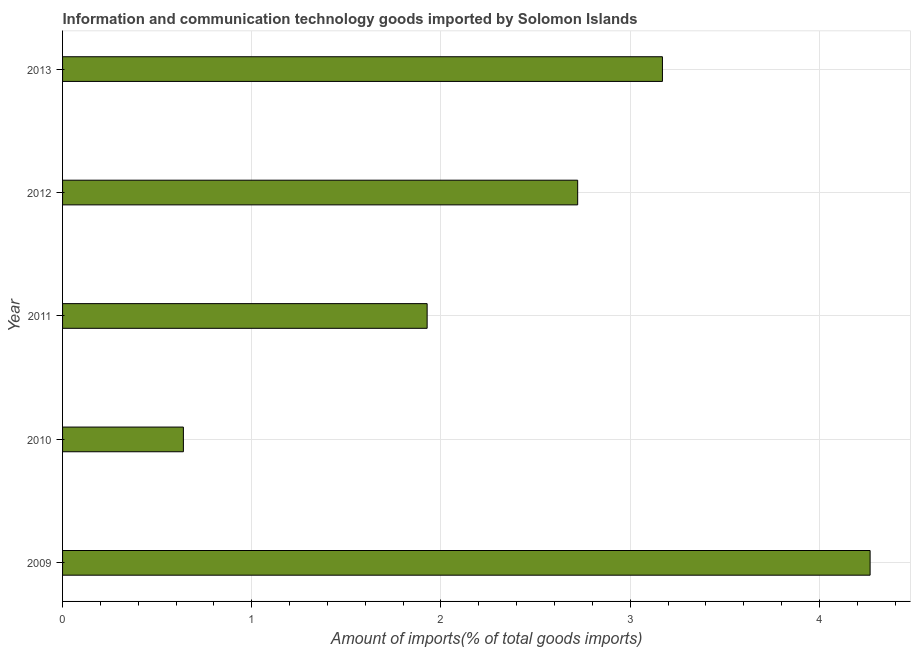What is the title of the graph?
Provide a short and direct response. Information and communication technology goods imported by Solomon Islands. What is the label or title of the X-axis?
Offer a very short reply. Amount of imports(% of total goods imports). What is the amount of ict goods imports in 2009?
Your answer should be compact. 4.27. Across all years, what is the maximum amount of ict goods imports?
Make the answer very short. 4.27. Across all years, what is the minimum amount of ict goods imports?
Offer a very short reply. 0.64. In which year was the amount of ict goods imports minimum?
Offer a terse response. 2010. What is the sum of the amount of ict goods imports?
Give a very brief answer. 12.73. What is the difference between the amount of ict goods imports in 2010 and 2011?
Offer a terse response. -1.29. What is the average amount of ict goods imports per year?
Provide a succinct answer. 2.54. What is the median amount of ict goods imports?
Make the answer very short. 2.72. In how many years, is the amount of ict goods imports greater than 1.2 %?
Your answer should be very brief. 4. What is the ratio of the amount of ict goods imports in 2010 to that in 2011?
Offer a very short reply. 0.33. Is the amount of ict goods imports in 2009 less than that in 2010?
Offer a terse response. No. What is the difference between the highest and the second highest amount of ict goods imports?
Make the answer very short. 1.1. What is the difference between the highest and the lowest amount of ict goods imports?
Make the answer very short. 3.63. In how many years, is the amount of ict goods imports greater than the average amount of ict goods imports taken over all years?
Your answer should be compact. 3. What is the difference between two consecutive major ticks on the X-axis?
Offer a terse response. 1. Are the values on the major ticks of X-axis written in scientific E-notation?
Your answer should be compact. No. What is the Amount of imports(% of total goods imports) in 2009?
Give a very brief answer. 4.27. What is the Amount of imports(% of total goods imports) in 2010?
Ensure brevity in your answer.  0.64. What is the Amount of imports(% of total goods imports) in 2011?
Your answer should be very brief. 1.93. What is the Amount of imports(% of total goods imports) in 2012?
Offer a very short reply. 2.72. What is the Amount of imports(% of total goods imports) in 2013?
Your answer should be compact. 3.17. What is the difference between the Amount of imports(% of total goods imports) in 2009 and 2010?
Keep it short and to the point. 3.63. What is the difference between the Amount of imports(% of total goods imports) in 2009 and 2011?
Give a very brief answer. 2.34. What is the difference between the Amount of imports(% of total goods imports) in 2009 and 2012?
Your response must be concise. 1.55. What is the difference between the Amount of imports(% of total goods imports) in 2009 and 2013?
Provide a short and direct response. 1.1. What is the difference between the Amount of imports(% of total goods imports) in 2010 and 2011?
Your answer should be very brief. -1.29. What is the difference between the Amount of imports(% of total goods imports) in 2010 and 2012?
Give a very brief answer. -2.08. What is the difference between the Amount of imports(% of total goods imports) in 2010 and 2013?
Provide a short and direct response. -2.53. What is the difference between the Amount of imports(% of total goods imports) in 2011 and 2012?
Provide a short and direct response. -0.8. What is the difference between the Amount of imports(% of total goods imports) in 2011 and 2013?
Offer a very short reply. -1.24. What is the difference between the Amount of imports(% of total goods imports) in 2012 and 2013?
Offer a terse response. -0.45. What is the ratio of the Amount of imports(% of total goods imports) in 2009 to that in 2010?
Your answer should be very brief. 6.68. What is the ratio of the Amount of imports(% of total goods imports) in 2009 to that in 2011?
Your answer should be very brief. 2.21. What is the ratio of the Amount of imports(% of total goods imports) in 2009 to that in 2012?
Offer a very short reply. 1.57. What is the ratio of the Amount of imports(% of total goods imports) in 2009 to that in 2013?
Provide a succinct answer. 1.35. What is the ratio of the Amount of imports(% of total goods imports) in 2010 to that in 2011?
Keep it short and to the point. 0.33. What is the ratio of the Amount of imports(% of total goods imports) in 2010 to that in 2012?
Provide a short and direct response. 0.23. What is the ratio of the Amount of imports(% of total goods imports) in 2010 to that in 2013?
Provide a succinct answer. 0.2. What is the ratio of the Amount of imports(% of total goods imports) in 2011 to that in 2012?
Make the answer very short. 0.71. What is the ratio of the Amount of imports(% of total goods imports) in 2011 to that in 2013?
Your response must be concise. 0.61. What is the ratio of the Amount of imports(% of total goods imports) in 2012 to that in 2013?
Your response must be concise. 0.86. 